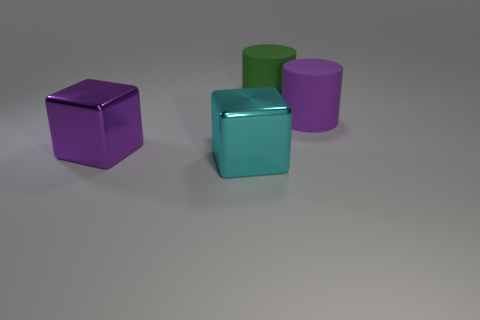Is the number of cyan metal blocks behind the big cyan cube greater than the number of purple matte cubes? no 